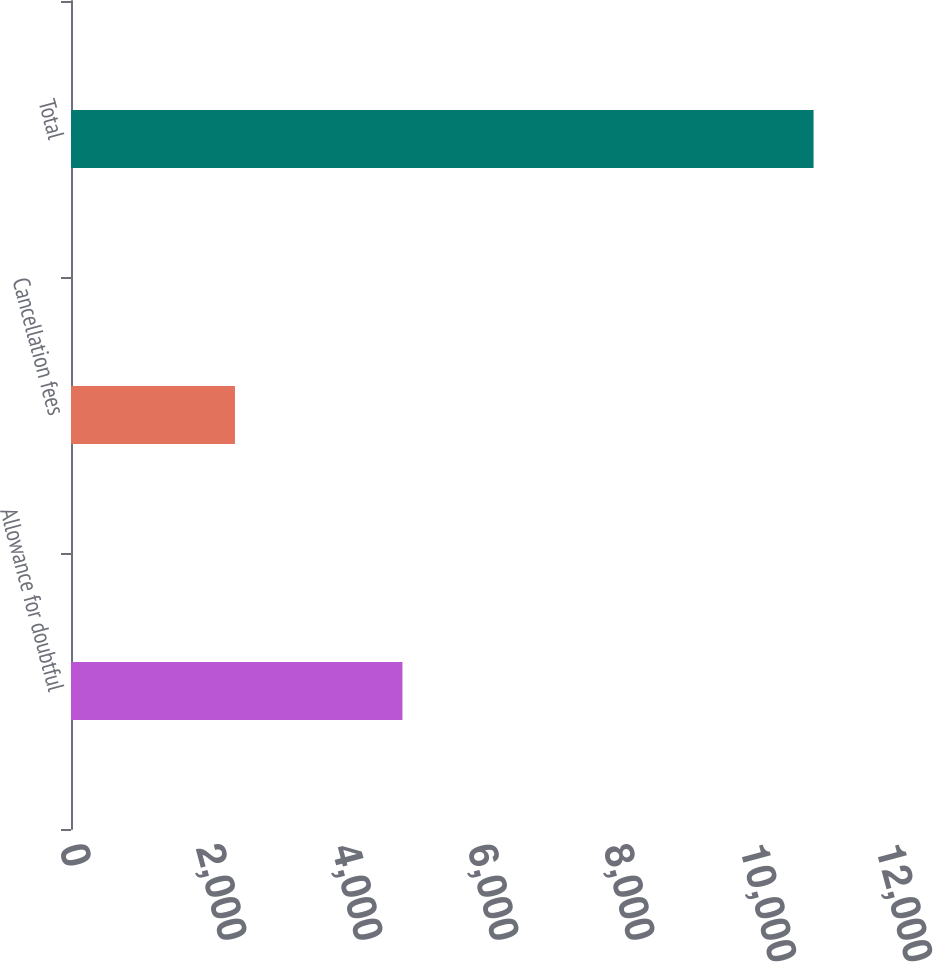Convert chart. <chart><loc_0><loc_0><loc_500><loc_500><bar_chart><fcel>Allowance for doubtful<fcel>Cancellation fees<fcel>Total<nl><fcel>4874<fcel>2411<fcel>10920<nl></chart> 